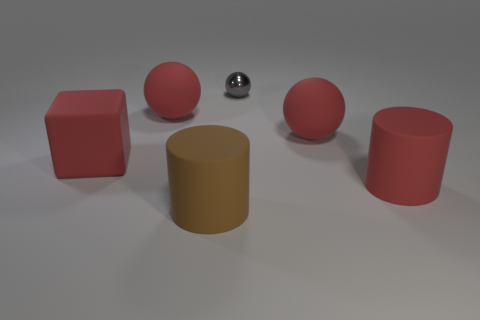Subtract all purple blocks. Subtract all purple cylinders. How many blocks are left? 1 Add 2 cubes. How many objects exist? 8 Subtract all cylinders. How many objects are left? 4 Add 4 matte objects. How many matte objects exist? 9 Subtract 1 red cylinders. How many objects are left? 5 Subtract all big red cylinders. Subtract all large blocks. How many objects are left? 4 Add 4 small spheres. How many small spheres are left? 5 